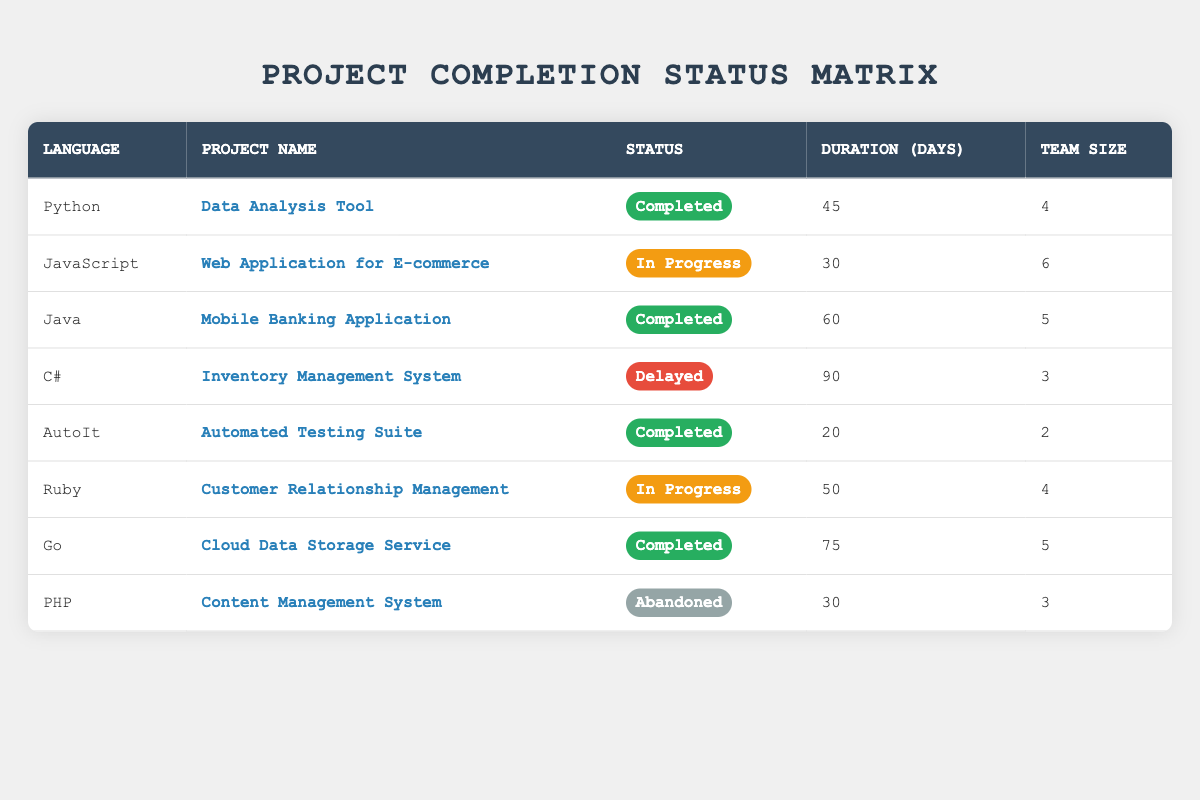What languages have completed projects? The table lists all projects along with their completion statuses. I will identify the languages associated with projects marked as "Completed". These are Python, Java, AutoIt, and Go.
Answer: Python, Java, AutoIt, Go How many team members were involved in the "Web Application for E-commerce" project? Looking at the row for the "Web Application for E-commerce", I see that the team size is specified as 6 members.
Answer: 6 Which project had the longest duration? I will check the duration for each project listed in the table, focusing on the "Duration (Days)" column. The project with the longest duration is the "Inventory Management System" with 90 days.
Answer: Inventory Management System Is the "Content Management System" project completed? The status for the "Content Management System" project is listed as "Abandoned". This means it is not completed.
Answer: No How many programming languages have projects listed as "In Progress"? By scanning the completion status of each project in the table, I find that the "Web Application for E-commerce" and "Customer Relationship Management" projects are both "In Progress". So, there are 2 such languages.
Answer: 2 What is the average team size of all completed projects? To find the average team size, I will first compile the team sizes of all completed projects: Python (4), Java (5), AutoIt (2), Go (5). The total is 4 + 5 + 2 + 5 = 16. There are 4 completed projects, so the average team size is 16 / 4 = 4.
Answer: 4 How many projects are categorized as delayed? I will look through the table and count how many projects have the status "Delayed". There is only one project, the "Inventory Management System", marked as delayed.
Answer: 1 Which programming language has the least duration among completed projects? Reviewing the durations for the completed projects: Python (45 days), Java (60 days), AutoIt (20 days), Go (75 days). The project with the least duration is "Automated Testing Suite" using AutoIt with 20 days.
Answer: AutoIt Are there any projects that have been abandoned? Checking the completion status across all projects, I find that the "Content Management System" project is marked as "Abandoned". This confirms that there is at least one project abandoned.
Answer: Yes 